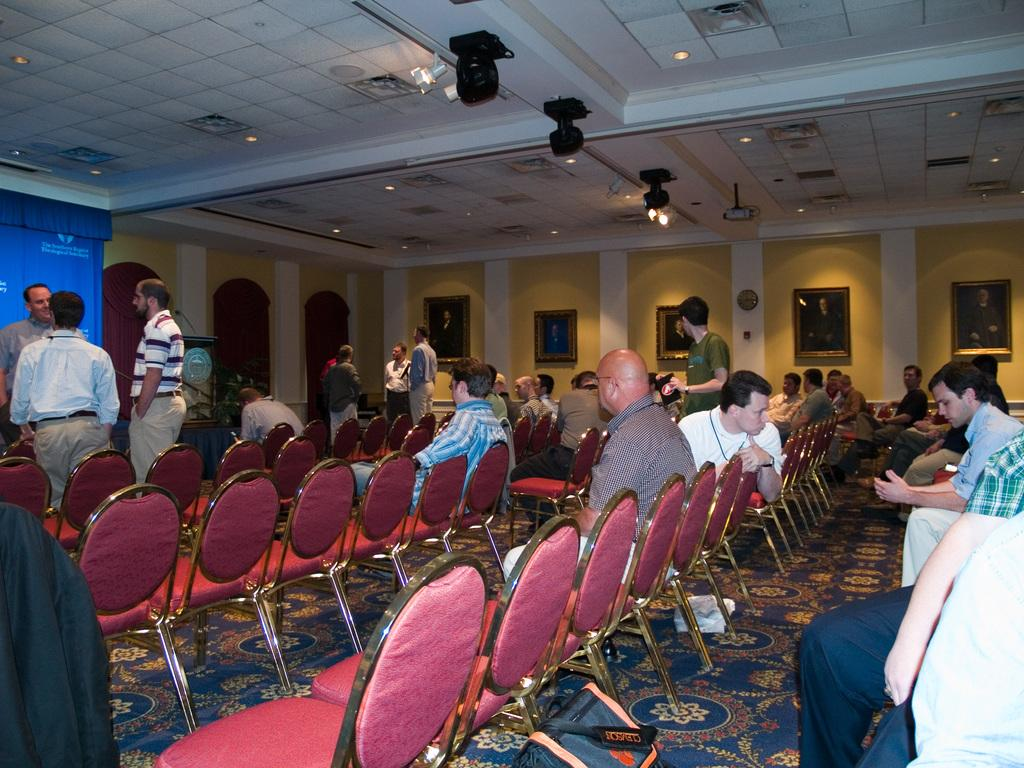What color are the chairs that the people are sitting on? The chairs are red. What are the people in the left corner of the image doing? The people in the left corner of the image are standing. Are there any giants visible in the image? No, there are no giants present in the image. What suggestion can be made to the people standing in the left corner of the image? The provided facts do not offer any information about making suggestions to the people in the image. 